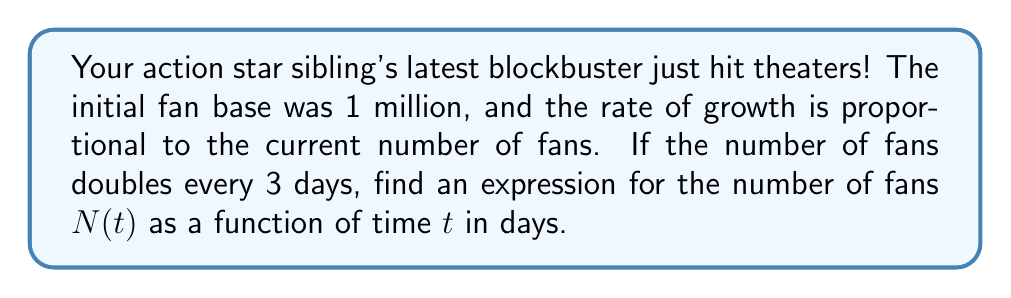Provide a solution to this math problem. Let's approach this step-by-step:

1) We're dealing with exponential growth, which can be modeled by the differential equation:

   $$\frac{dN}{dt} = kN$$

   where $k$ is the growth rate constant.

2) We're told that the number of fans doubles every 3 days. Let's use this to find $k$:

   $$N(3) = 2N(0)$$
   $$N_0e^{3k} = 2N_0$$
   $$e^{3k} = 2$$
   $$3k = \ln(2)$$
   $$k = \frac{\ln(2)}{3}$$

3) Now we have our complete differential equation:

   $$\frac{dN}{dt} = \frac{\ln(2)}{3}N$$

4) The general solution to this equation is:

   $$N(t) = N_0e^{\frac{\ln(2)}{3}t}$$

   where $N_0$ is the initial number of fans.

5) We're given that the initial fan base was 1 million, so $N_0 = 1,000,000$.

6) Substituting this into our equation:

   $$N(t) = 1,000,000e^{\frac{\ln(2)}{3}t}$$

This is our final expression for the number of fans as a function of time.
Answer: $N(t) = 1,000,000e^{\frac{\ln(2)}{3}t}$ 